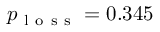Convert formula to latex. <formula><loc_0><loc_0><loc_500><loc_500>p _ { l o s s } = 0 . 3 4 5</formula> 